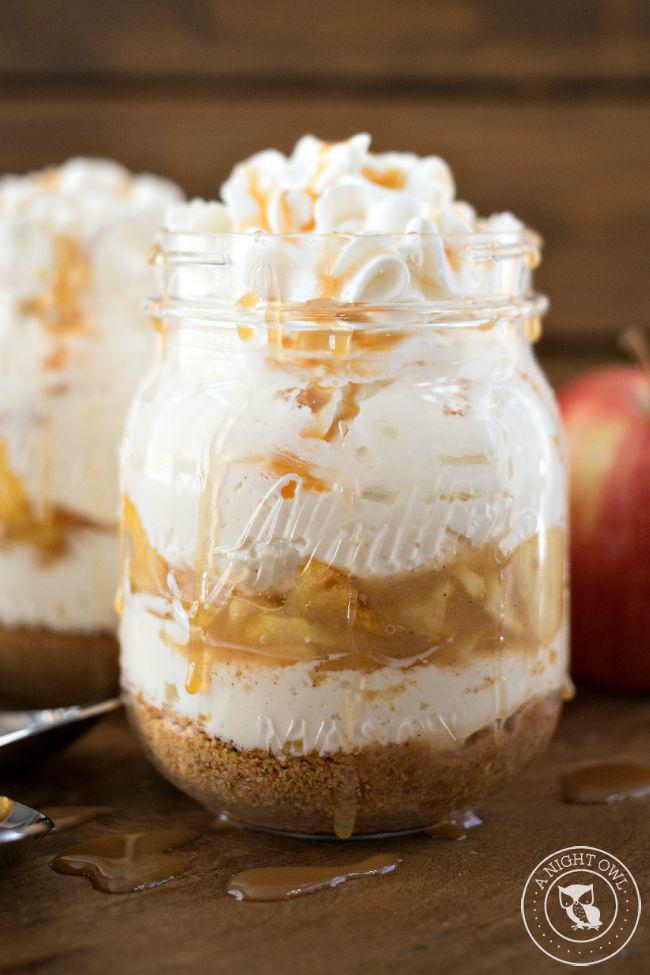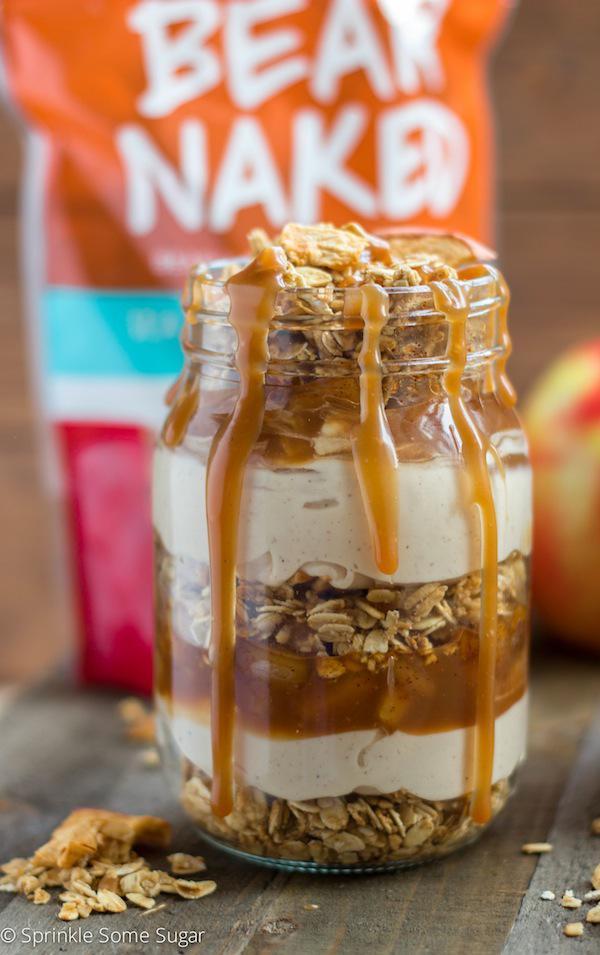The first image is the image on the left, the second image is the image on the right. For the images displayed, is the sentence "An image shows a dessert with two white layers, no whipped cream on top, and caramel drizzled down the exterior of the serving jar." factually correct? Answer yes or no. Yes. The first image is the image on the left, the second image is the image on the right. Evaluate the accuracy of this statement regarding the images: "Caramel is dripping over a jar of dessert.". Is it true? Answer yes or no. Yes. 